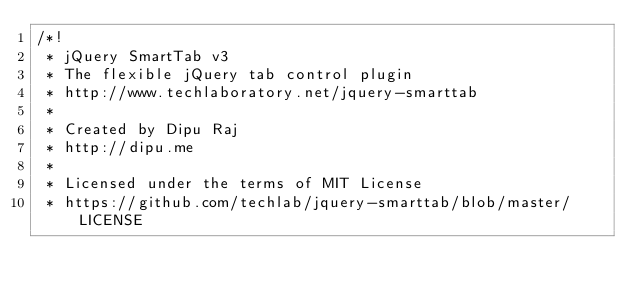Convert code to text. <code><loc_0><loc_0><loc_500><loc_500><_CSS_>/*!
 * jQuery SmartTab v3
 * The flexible jQuery tab control plugin
 * http://www.techlaboratory.net/jquery-smarttab
 *
 * Created by Dipu Raj
 * http://dipu.me
 *
 * Licensed under the terms of MIT License
 * https://github.com/techlab/jquery-smarttab/blob/master/LICENSE</code> 